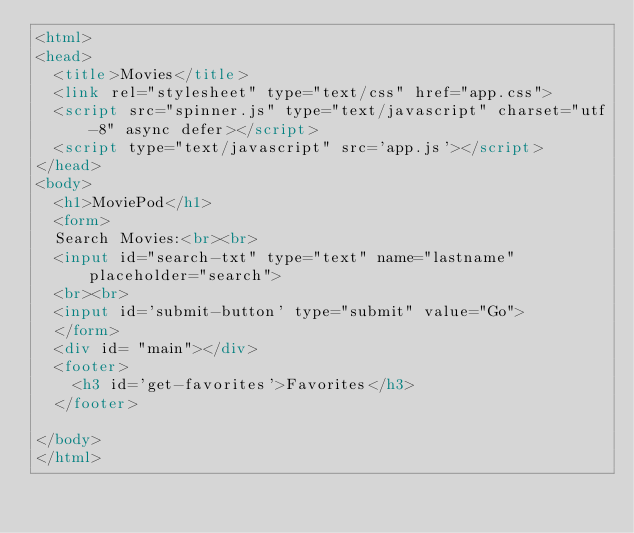Convert code to text. <code><loc_0><loc_0><loc_500><loc_500><_HTML_><html>
<head>
  <title>Movies</title>
  <link rel="stylesheet" type="text/css" href="app.css">
  <script src="spinner.js" type="text/javascript" charset="utf-8" async defer></script>
  <script type="text/javascript" src='app.js'></script>
</head>
<body>
  <h1>MoviePod</h1>
  <form>
  Search Movies:<br><br>
  <input id="search-txt" type="text" name="lastname" placeholder="search">
  <br><br>
  <input id='submit-button' type="submit" value="Go">
  </form>
  <div id= "main"></div>
  <footer>
    <h3 id='get-favorites'>Favorites</h3>
  </footer>

</body>
</html></code> 